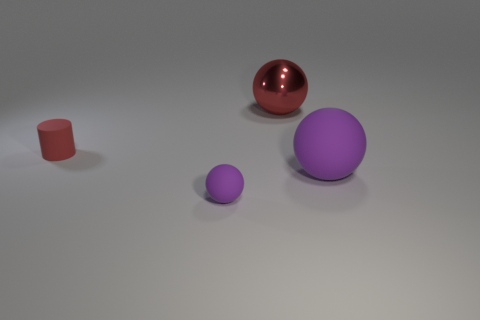The purple ball on the left side of the big ball behind the cylinder is made of what material?
Provide a short and direct response. Rubber. What number of things are either big balls behind the large rubber ball or big brown metallic cubes?
Make the answer very short. 1. Are there an equal number of rubber balls on the left side of the big red shiny thing and big metallic balls in front of the small purple ball?
Give a very brief answer. No. There is a small object that is behind the purple rubber ball that is on the right side of the purple sphere left of the large red metallic ball; what is it made of?
Keep it short and to the point. Rubber. There is a sphere that is both to the right of the small purple sphere and in front of the red sphere; what size is it?
Your response must be concise. Large. Is the shape of the large shiny thing the same as the large rubber object?
Your response must be concise. Yes. What is the shape of the large purple object that is the same material as the red cylinder?
Your answer should be very brief. Sphere. What number of small things are either red spheres or purple cubes?
Offer a very short reply. 0. Is there a large sphere that is behind the large object that is in front of the tiny red thing?
Provide a short and direct response. Yes. Is there a large cyan metal ball?
Provide a short and direct response. No. 